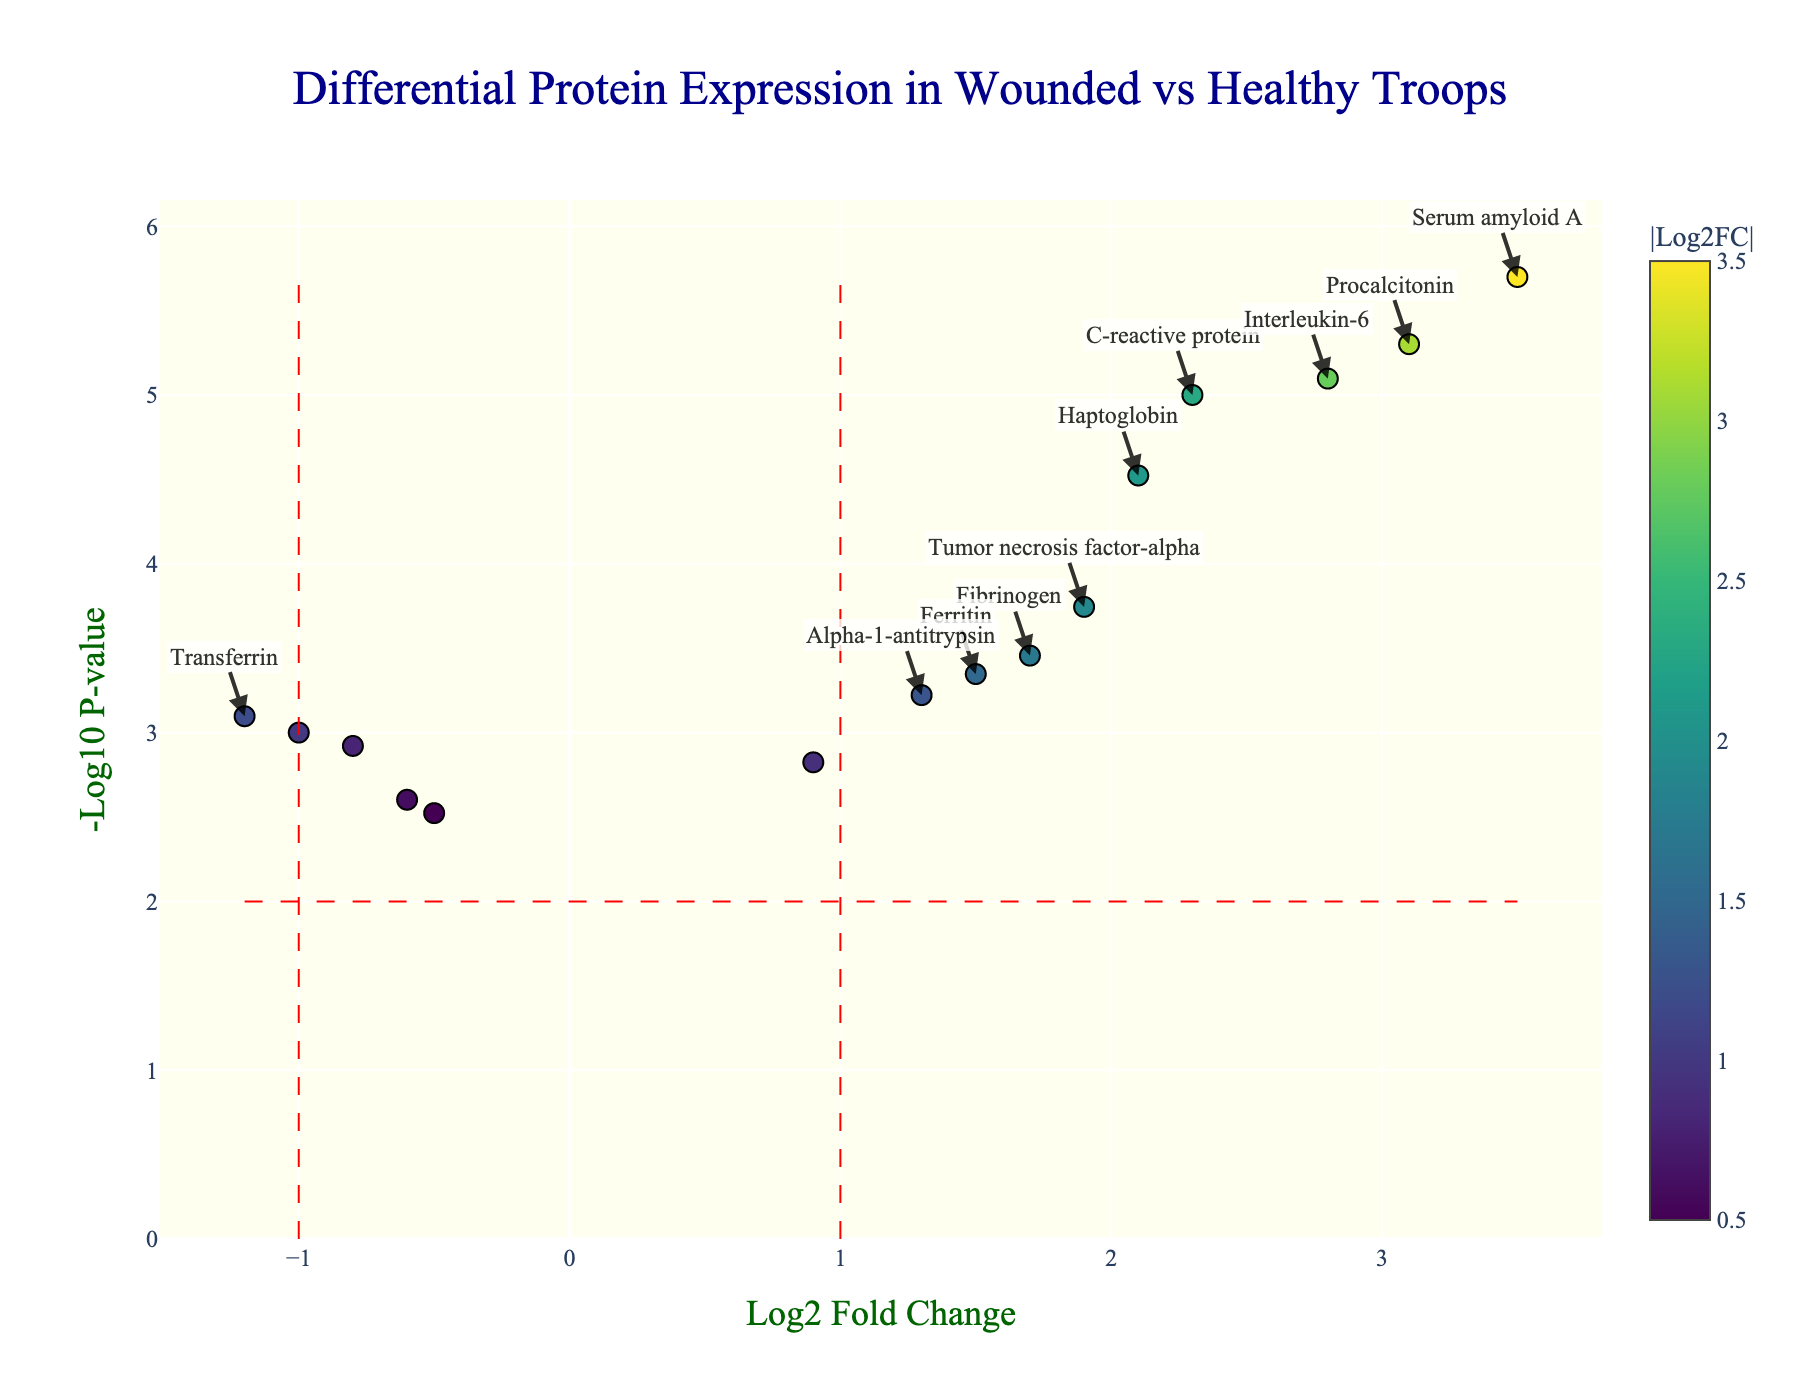Which protein has the highest log2 Fold Change? To find the protein with the highest log2 Fold Change, look at the x-axis values and identify the data point farthest to the right. Based on the hover information for each protein, Procalcitonin has the highest log2 Fold Change of 3.1.
Answer: Procalcitonin How many proteins show a negative log2 Fold Change? To determine the number of proteins with a negative log2 Fold Change, count the data points located to the left of the zero on the x-axis. By checking each data point, the proteins with negative log2 Fold Changes are Albumin, Transferrin, Complement C3, Complement C4, and Retinol-binding protein, totaling 5.
Answer: 5 Which protein has the lowest p-value? To find the protein with the lowest p-value, look at the y-axis for the highest -log10 p-value and check the corresponding data point. Serum amyloid A has the highest -log10 p-value of 6.69, indicating the lowest p-value.
Answer: Serum amyloid A What is the threshold for significance in p-value on the plot? The horizontal red dashed line represents the p-value threshold, which is given by -log10(p-value) = -log10(0.01). Calculating this, the threshold is 2.
Answer: 0.01 How many proteins meet both the log2 Fold Change threshold and the p-value threshold? To identify proteins that meet both thresholds, count the annotated proteins: these are the ones on the right/left of the vertical lines and above the horizontal line. The significant proteins are C-reactive protein, Fibrinogen, Procalcitonin, Interleukin-6, Tumor necrosis factor-alpha, Haptoglobin, Serum amyloid A, Ferritin, Alpha-1-antitrypsin, and Transferrin, totaling 10.
Answer: 10 